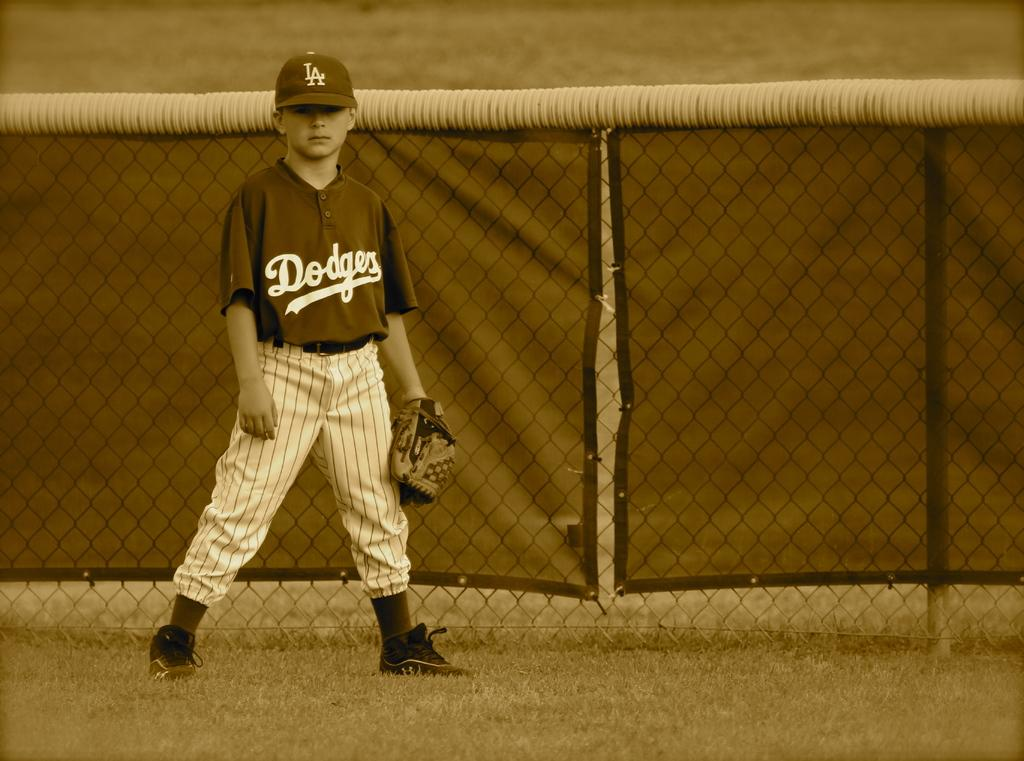<image>
Create a compact narrative representing the image presented. a player that is wearing a Dodgers jersey 